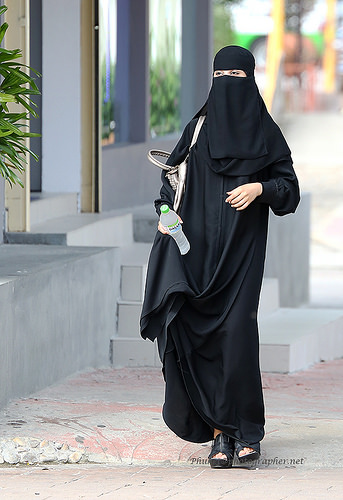<image>
Is there a water on the stairs? No. The water is not positioned on the stairs. They may be near each other, but the water is not supported by or resting on top of the stairs. 